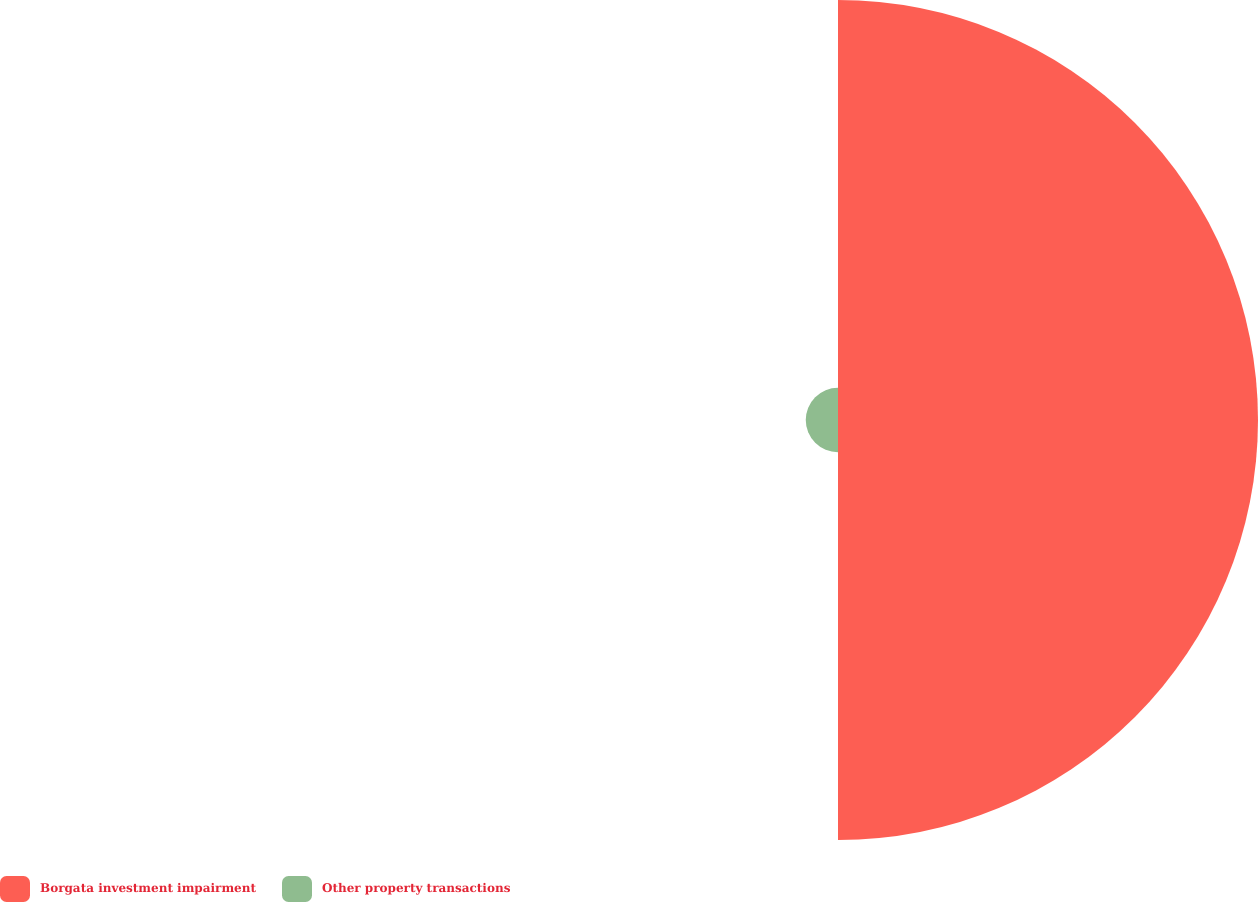<chart> <loc_0><loc_0><loc_500><loc_500><pie_chart><fcel>Borgata investment impairment<fcel>Other property transactions<nl><fcel>92.87%<fcel>7.13%<nl></chart> 